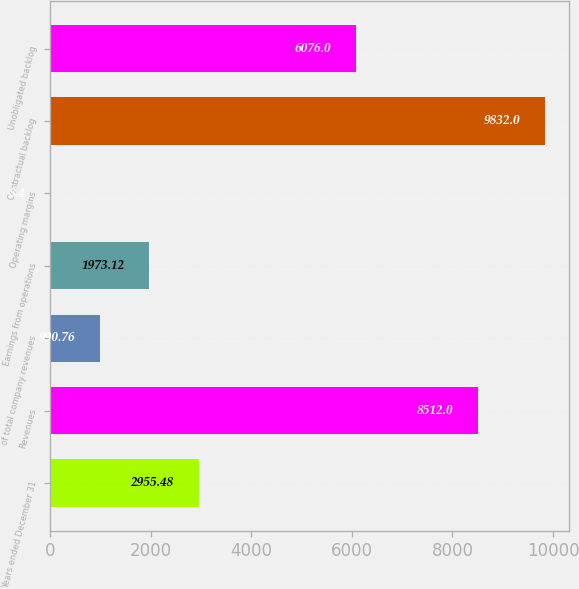Convert chart to OTSL. <chart><loc_0><loc_0><loc_500><loc_500><bar_chart><fcel>Years ended December 31<fcel>Revenues<fcel>of total company revenues<fcel>Earnings from operations<fcel>Operating margins<fcel>Contractual backlog<fcel>Unobligated backlog<nl><fcel>2955.48<fcel>8512<fcel>990.76<fcel>1973.12<fcel>8.4<fcel>9832<fcel>6076<nl></chart> 